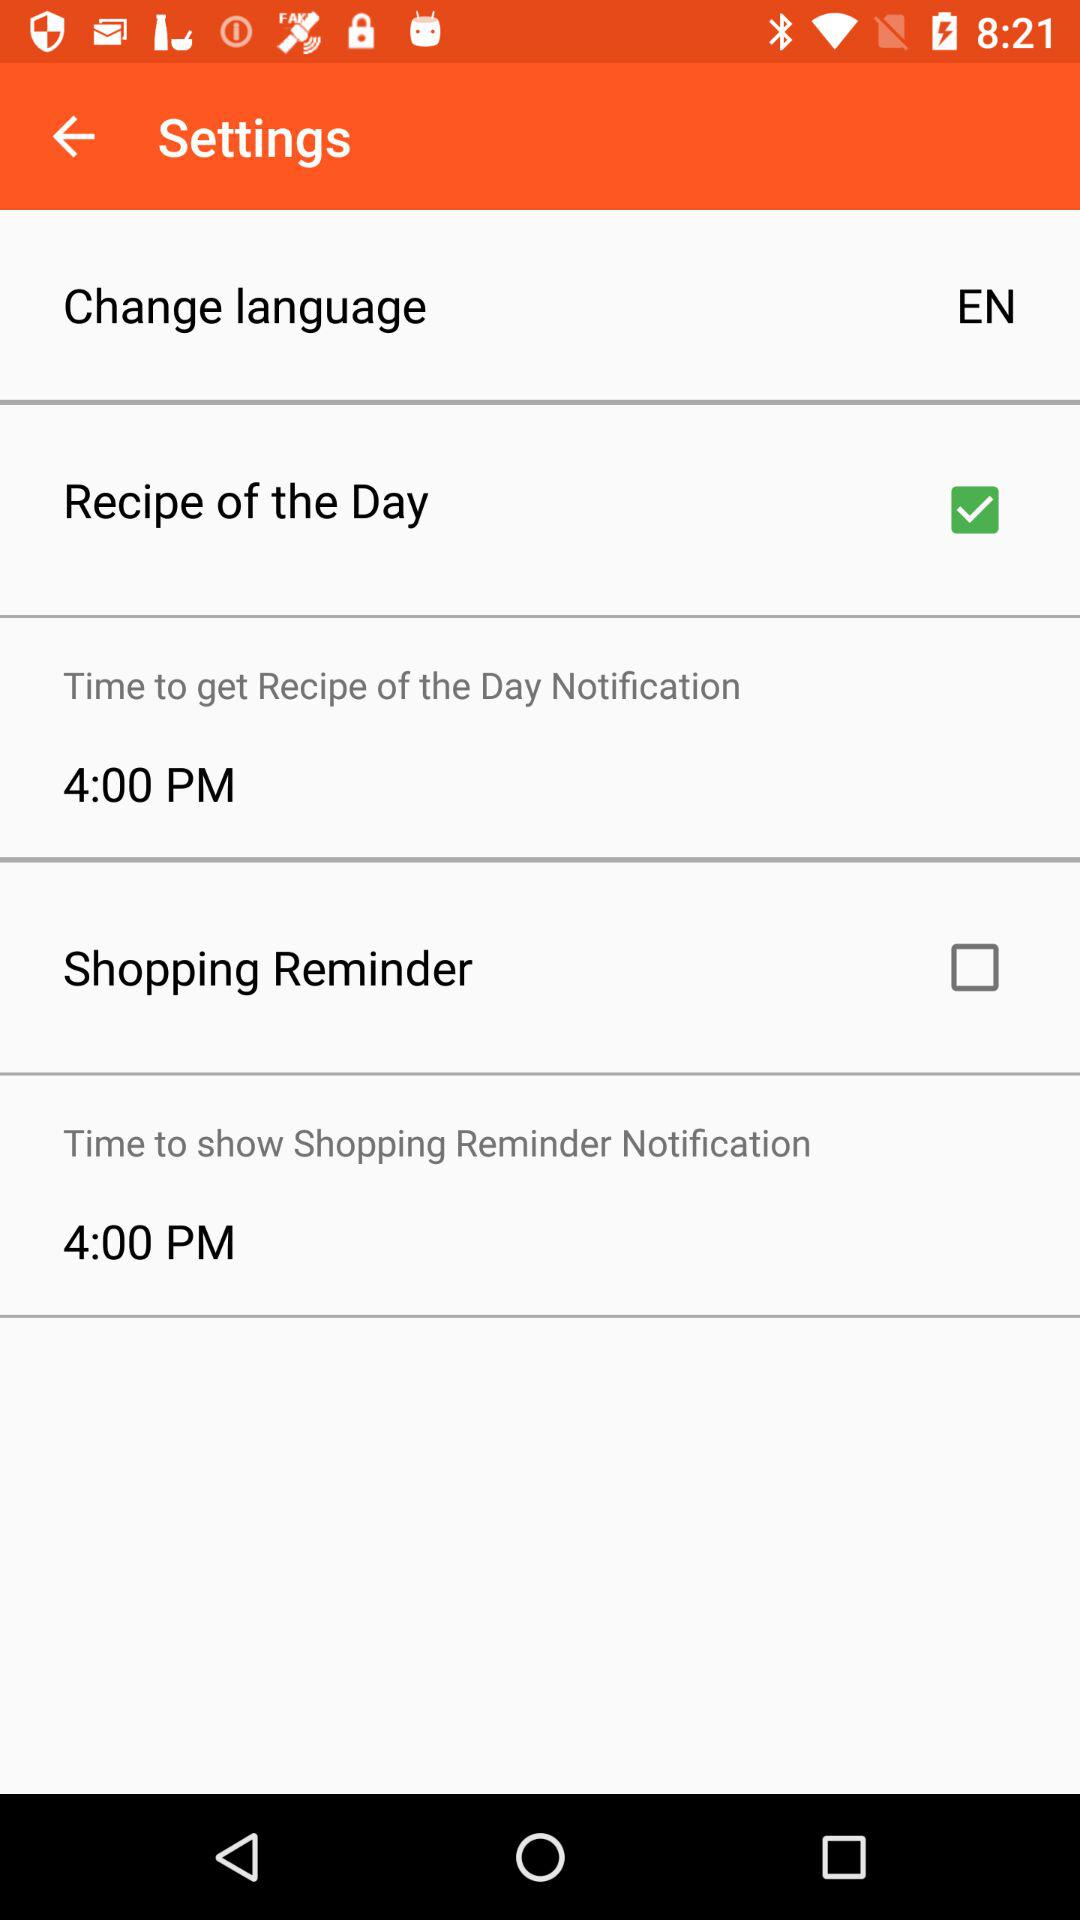What's the time to show the shopping reminder notification? The time is 4:00 PM. 